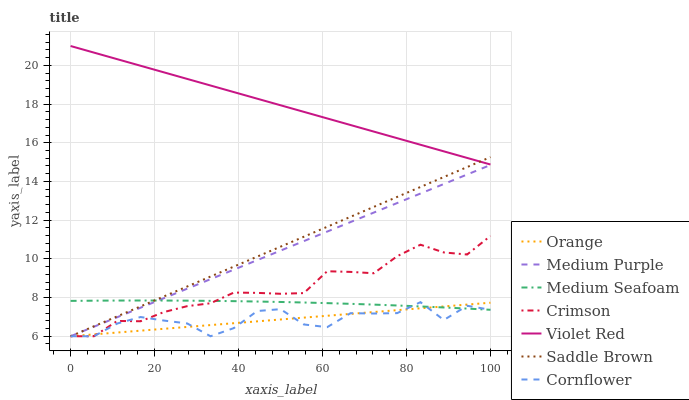Does Orange have the minimum area under the curve?
Answer yes or no. Yes. Does Violet Red have the maximum area under the curve?
Answer yes or no. Yes. Does Saddle Brown have the minimum area under the curve?
Answer yes or no. No. Does Saddle Brown have the maximum area under the curve?
Answer yes or no. No. Is Orange the smoothest?
Answer yes or no. Yes. Is Cornflower the roughest?
Answer yes or no. Yes. Is Violet Red the smoothest?
Answer yes or no. No. Is Violet Red the roughest?
Answer yes or no. No. Does Violet Red have the lowest value?
Answer yes or no. No. Does Violet Red have the highest value?
Answer yes or no. Yes. Does Saddle Brown have the highest value?
Answer yes or no. No. Is Medium Purple less than Violet Red?
Answer yes or no. Yes. Is Violet Red greater than Orange?
Answer yes or no. Yes. Does Orange intersect Medium Seafoam?
Answer yes or no. Yes. Is Orange less than Medium Seafoam?
Answer yes or no. No. Is Orange greater than Medium Seafoam?
Answer yes or no. No. Does Medium Purple intersect Violet Red?
Answer yes or no. No. 